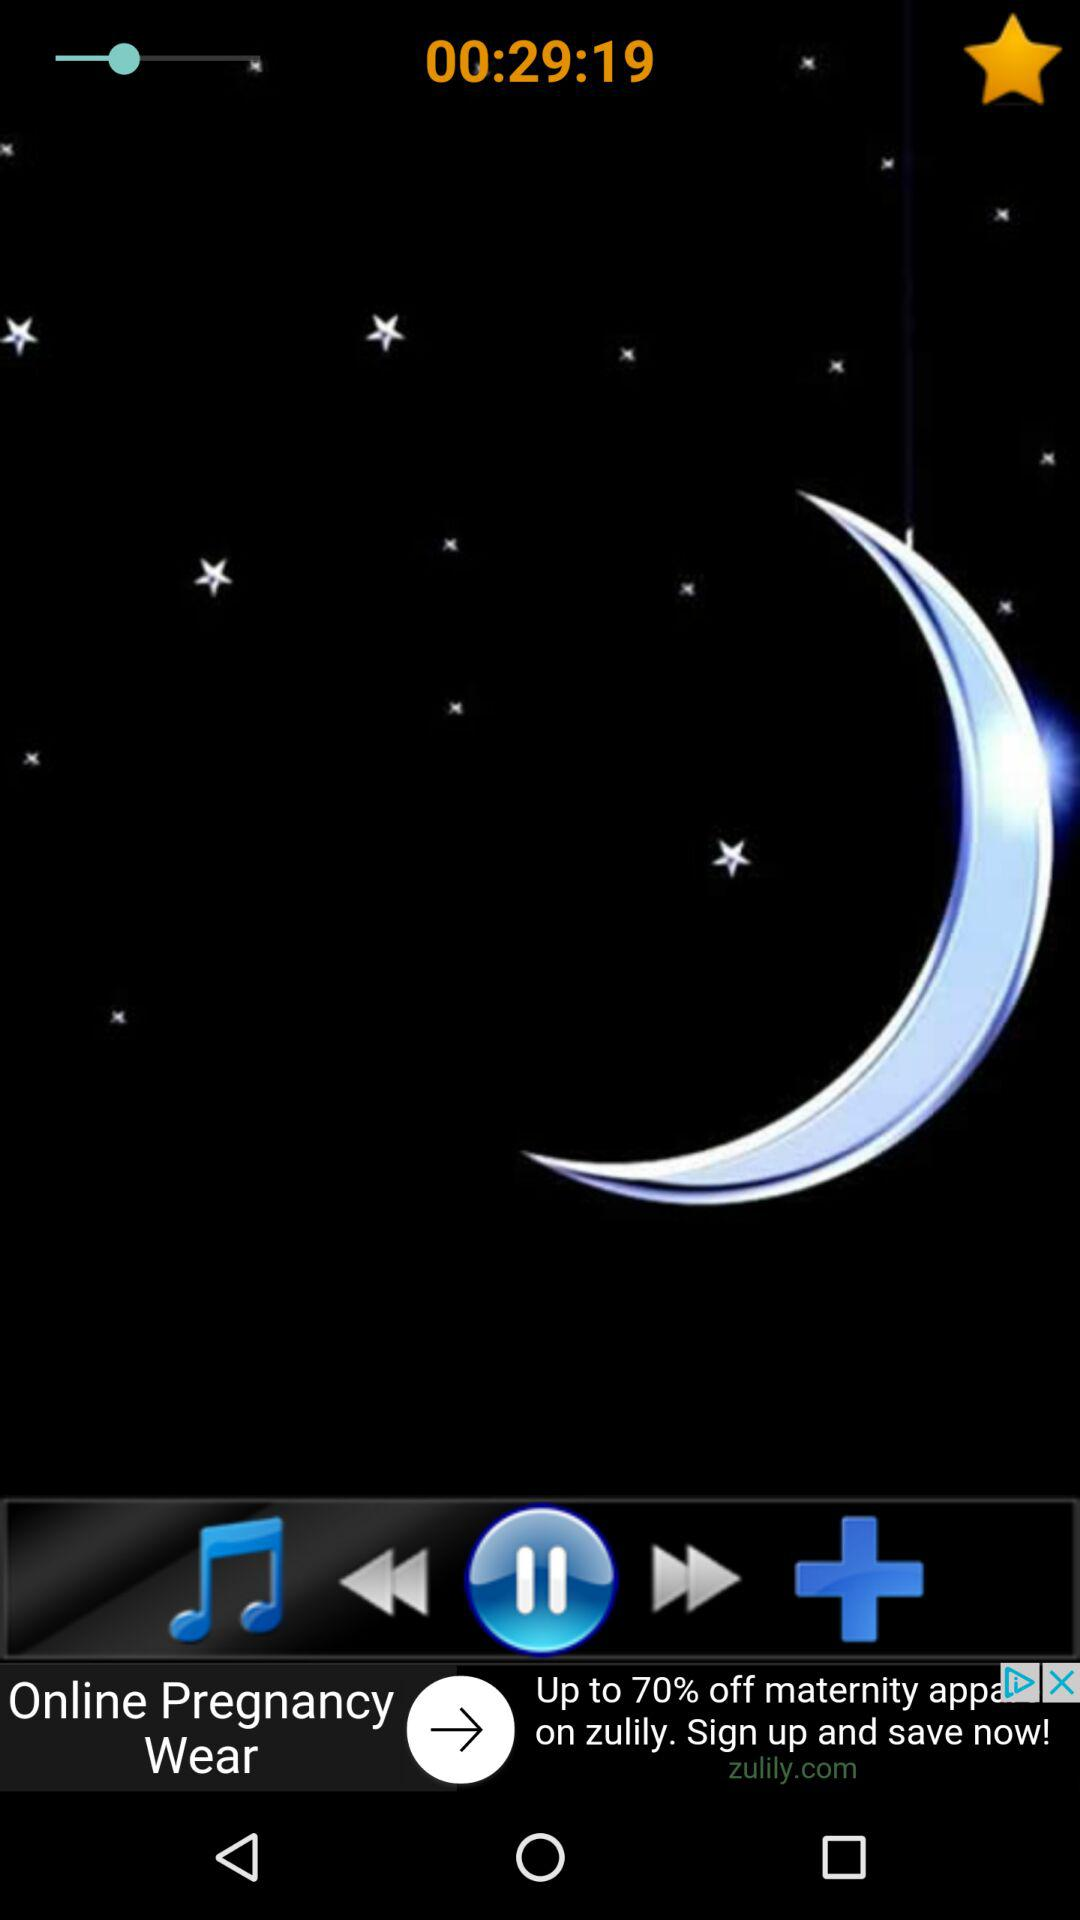What is the duration? The duration is 29 minutes 19 seconds. 